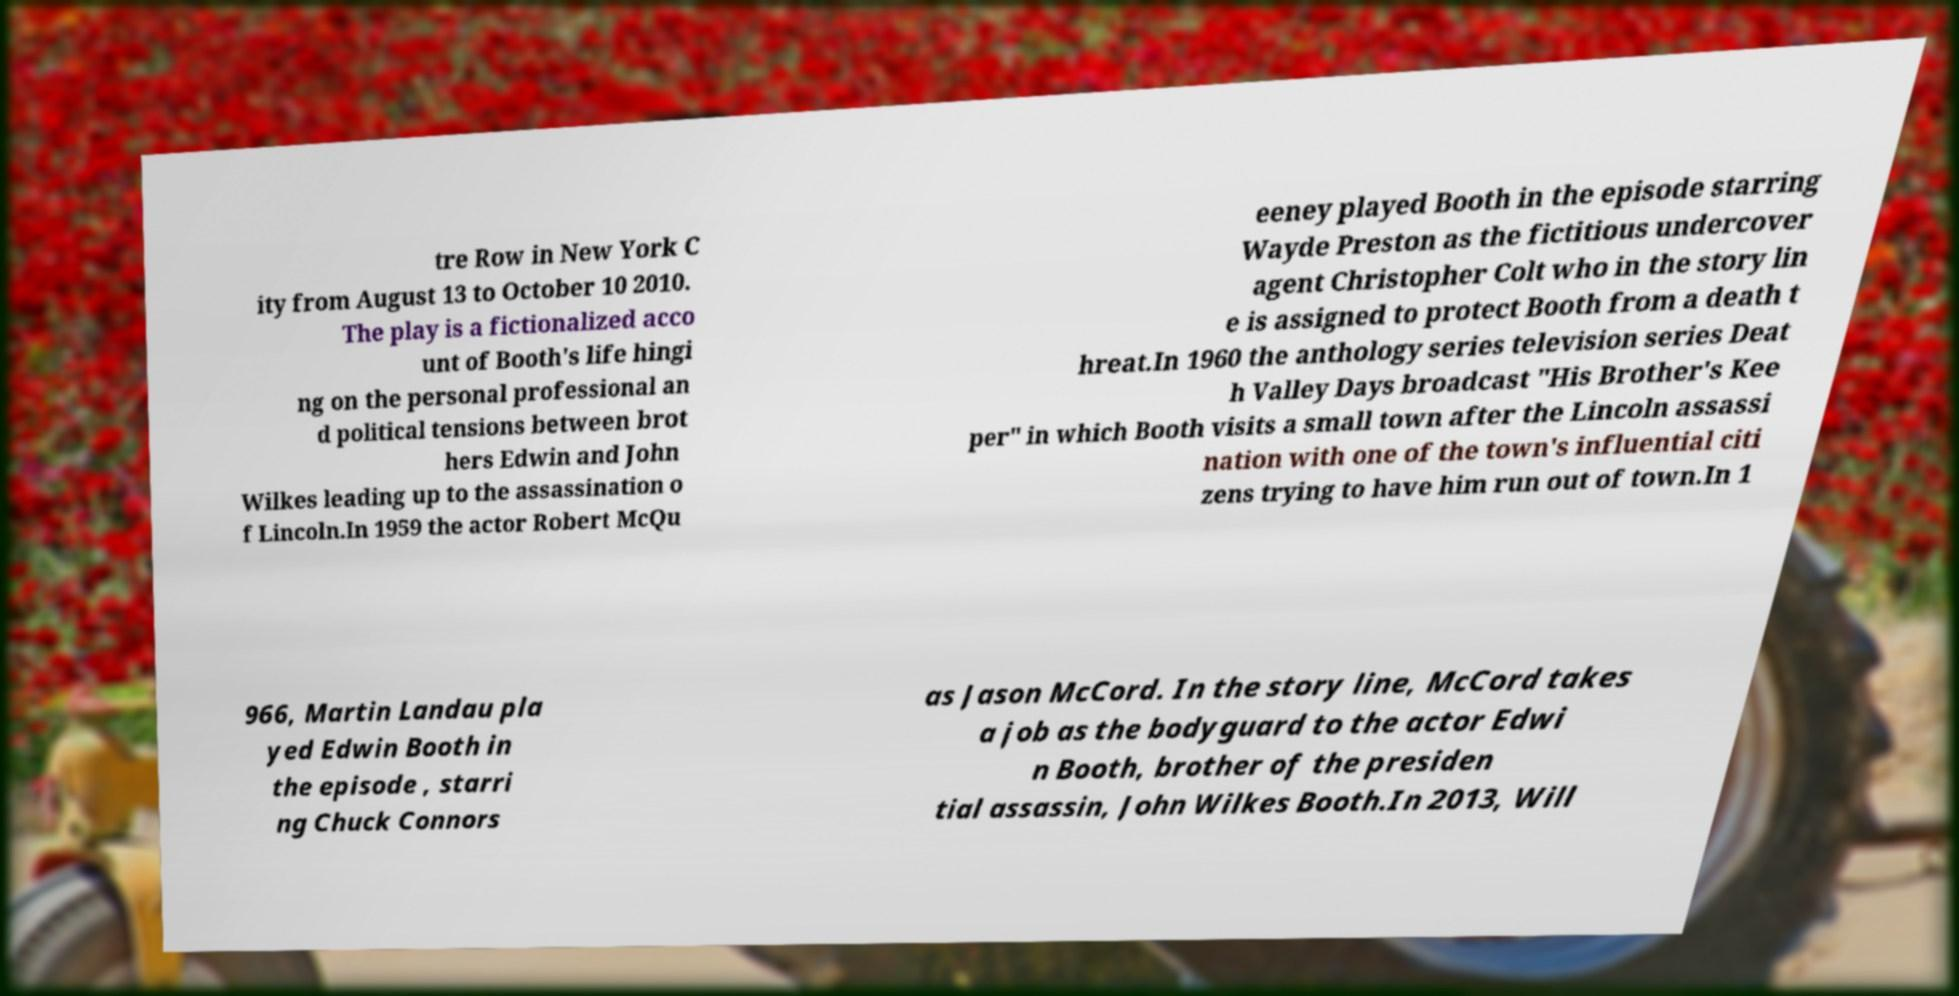There's text embedded in this image that I need extracted. Can you transcribe it verbatim? tre Row in New York C ity from August 13 to October 10 2010. The play is a fictionalized acco unt of Booth's life hingi ng on the personal professional an d political tensions between brot hers Edwin and John Wilkes leading up to the assassination o f Lincoln.In 1959 the actor Robert McQu eeney played Booth in the episode starring Wayde Preston as the fictitious undercover agent Christopher Colt who in the story lin e is assigned to protect Booth from a death t hreat.In 1960 the anthology series television series Deat h Valley Days broadcast "His Brother's Kee per" in which Booth visits a small town after the Lincoln assassi nation with one of the town's influential citi zens trying to have him run out of town.In 1 966, Martin Landau pla yed Edwin Booth in the episode , starri ng Chuck Connors as Jason McCord. In the story line, McCord takes a job as the bodyguard to the actor Edwi n Booth, brother of the presiden tial assassin, John Wilkes Booth.In 2013, Will 